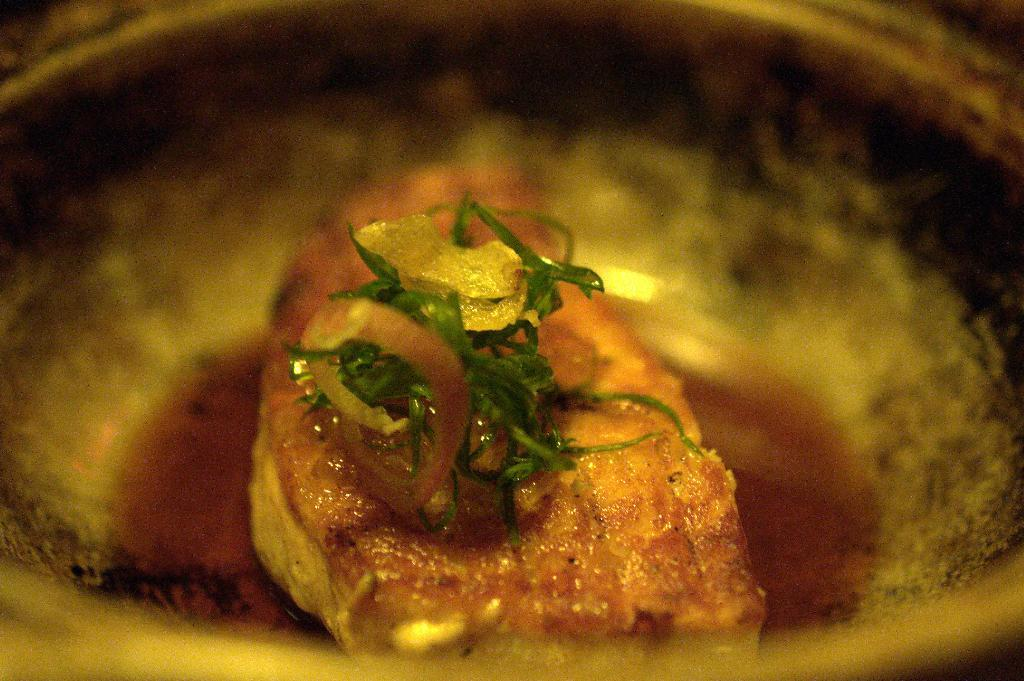What is the main subject of the image? There is a food item in a bowl in the image. Can you describe the background of the image? The background of the image is blurred. What type of news is being reported on the goat in the image? There is no goat or news report present in the image. 